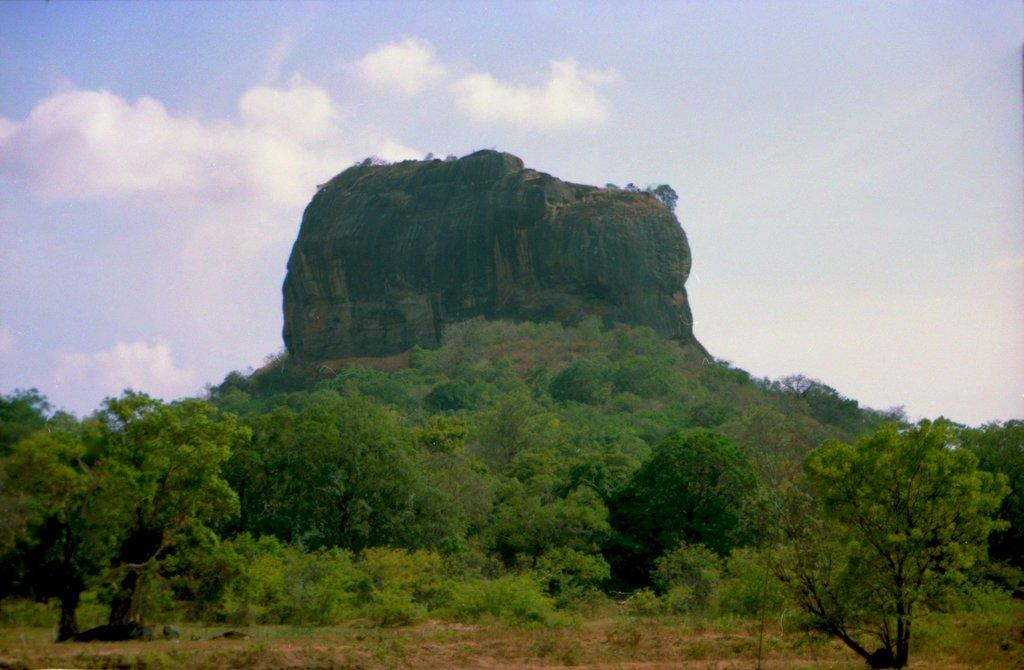What types of vegetation are present in the image? The image contains plants and trees. What can be seen in the background of the image? There is a rocky hill in the background of the image. What is visible in the sky in the image? The sky is visible in the background of the image, and clouds are present. What is the number of buildings visible in the image? There are no buildings visible in the image; it contains plants, trees, a rocky hill, and the sky with clouds. 